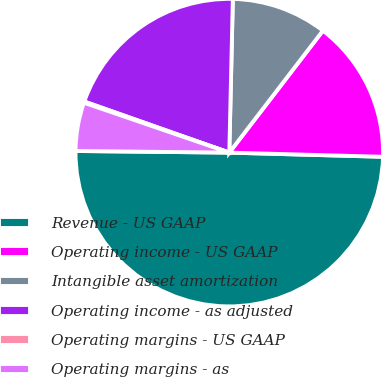Convert chart. <chart><loc_0><loc_0><loc_500><loc_500><pie_chart><fcel>Revenue - US GAAP<fcel>Operating income - US GAAP<fcel>Intangible asset amortization<fcel>Operating income - as adjusted<fcel>Operating margins - US GAAP<fcel>Operating margins - as<nl><fcel>49.73%<fcel>15.01%<fcel>10.05%<fcel>19.97%<fcel>0.13%<fcel>5.09%<nl></chart> 